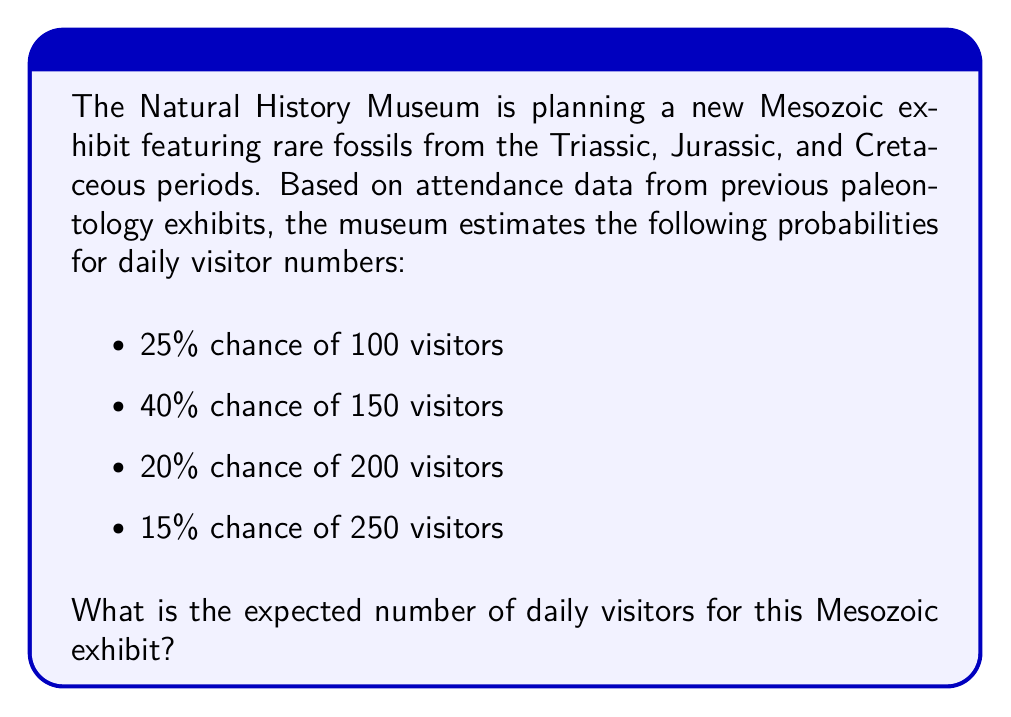Can you answer this question? To calculate the expected number of daily visitors, we need to use the concept of expected value. The expected value is the sum of each possible outcome multiplied by its probability.

Let's break it down step-by-step:

1) First, let's define our random variable $X$ as the number of daily visitors.

2) We can express the expected value $E(X)$ as:

   $$E(X) = \sum_{i=1}^{n} x_i \cdot p(x_i)$$

   where $x_i$ is each possible outcome and $p(x_i)$ is its probability.

3) Now, let's calculate each term:

   - 100 visitors: $100 \cdot 0.25 = 25$
   - 150 visitors: $150 \cdot 0.40 = 60$
   - 200 visitors: $200 \cdot 0.20 = 40$
   - 250 visitors: $250 \cdot 0.15 = 37.5$

4) Sum up all these terms:

   $$E(X) = 25 + 60 + 40 + 37.5 = 162.5$$

Therefore, the expected number of daily visitors for the Mesozoic exhibit is 162.5.
Answer: 162.5 visitors 